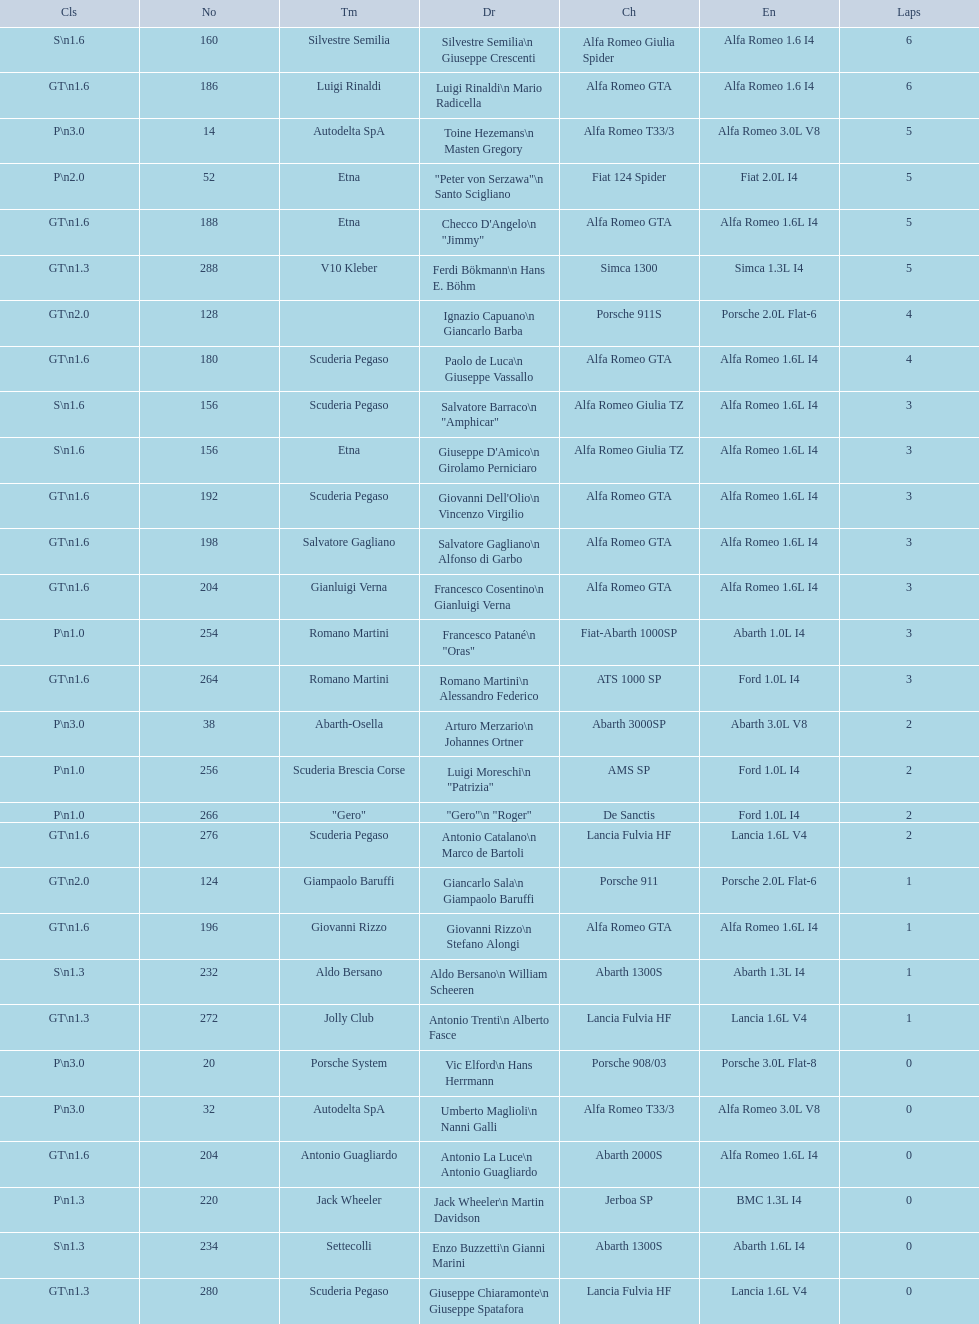Name the only american who did not finish the race. Masten Gregory. 